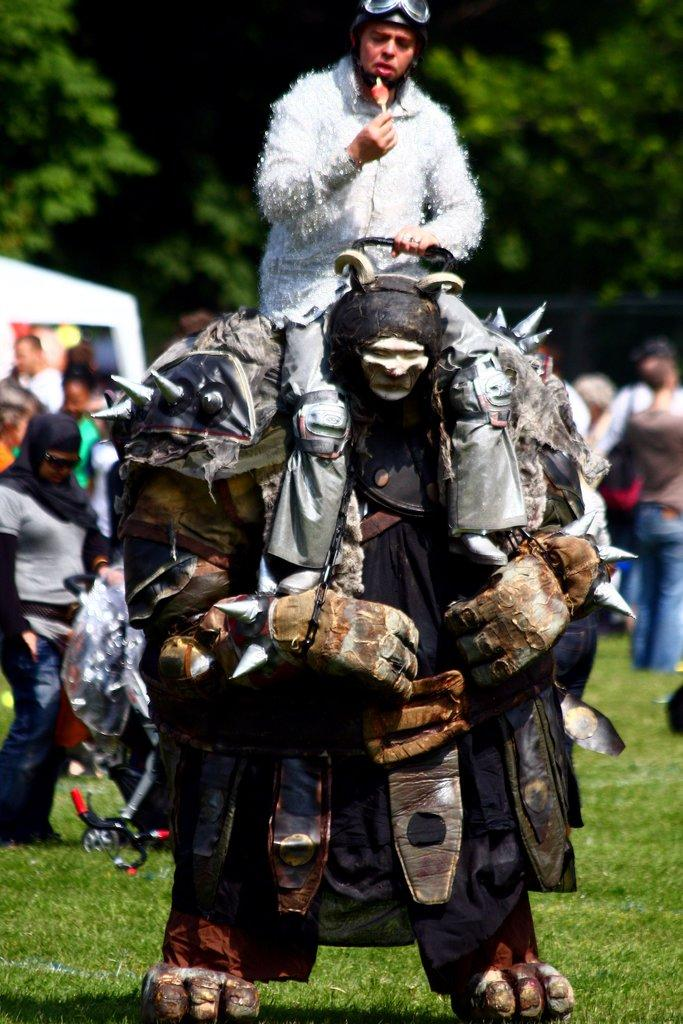What are the persons in the image doing? The persons in the image are holding an object. Can you describe the person with a costume? Yes, there is a person with a costume in the image. What type of natural environment is visible in the image? There are trees and grass in the image. What type of mark does the beetle leave on the grass in the image? There is no beetle present in the image, so it is not possible to determine what type of mark it might leave on the grass. --- Facts: 1. There is a person holding a book in the image. 2. The person is sitting on a chair. 3. There is a table in the image. 4. The table has a lamp on it. 5. There is a window in the image. Absurd Topics: parrot, ocean, bicycle Conversation: What is the person in the image holding? The person in the image is holding a book. Can you describe the person's seating arrangement? The person is sitting on a chair. What object is on the table in the image? There is a lamp on the table in the image. What is visible through the window in the image? Unfortunately, the facts provided do not mention what is visible through the window. Reasoning: Let's think step by step in order to produce the conversation. We start by identifying the main object the person is holding, which is a book. Then, we describe the person's seating arrangement, noting that they are sitting on a chair. Next, we mention the object on the table, which is a lamp. Finally, we acknowledge the presence of a window in the image but cannot provide any details about what is visible through it, as that information is not available in the provided facts. Absurd Question/Answer: Can you tell me how many parrots are sitting on the bicycle in the image? There is no bicycle or parrot present in the image, so it is not possible to determine how many parrots might be sitting on a bicycle. 